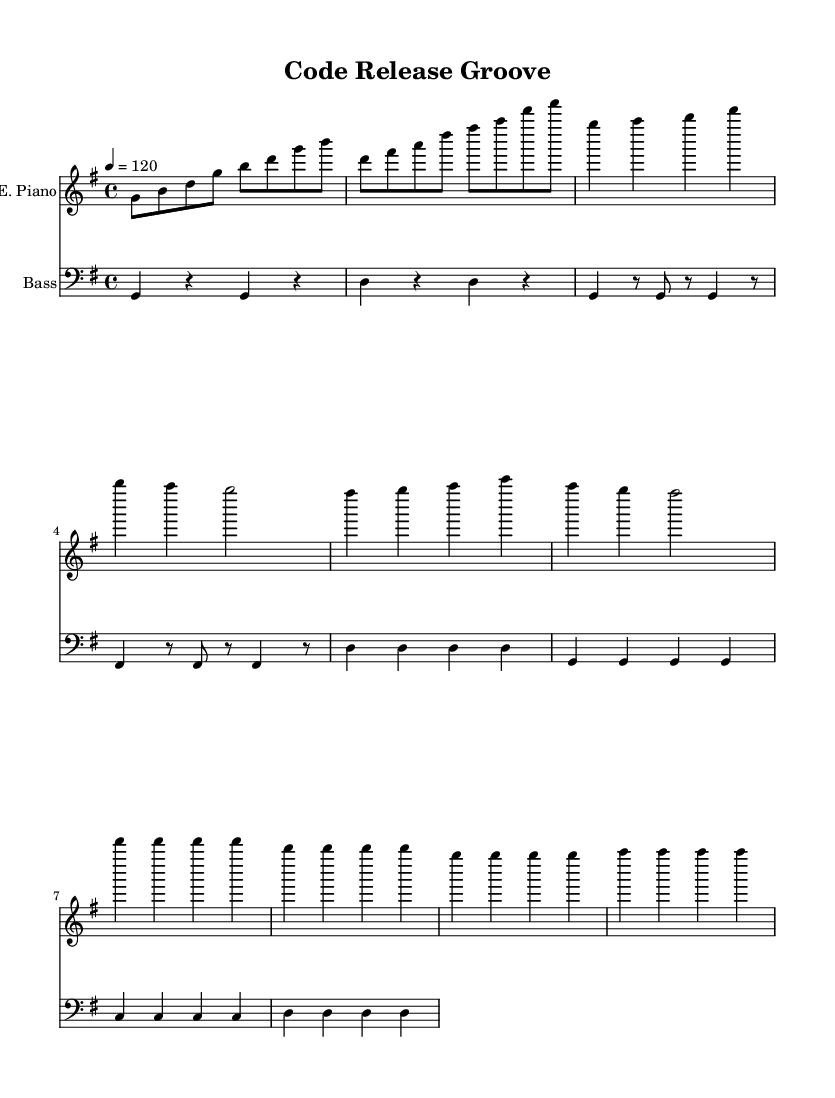What is the key signature of this music? The key signature is G major, which has one sharp (F#).
Answer: G major What is the time signature of this music? The time signature is 4/4, indicating four beats per measure.
Answer: 4/4 What is the tempo of this piece? The tempo is marked at 120 beats per minute.
Answer: 120 What is the instrument for the first staff? The first staff is for the electric piano, indicated by the instrument name above it.
Answer: E. Piano How many measures are in the chorus section? The chorus consists of four measures, as noted by the repetition of the musical phrases.
Answer: 4 How do the verse and chorus differ rhythmically? The verse features a mix of eighth and quarter notes, while the chorus uses primarily quarter notes, creating a more driving rhythmic effect.
Answer: Different rhythms What characteristic makes this piece an R&B track? The upbeat tempo combined with funky rhythms and syncopated bass lines emphasizes danceability typical of R&B music.
Answer: Upbeat groove 